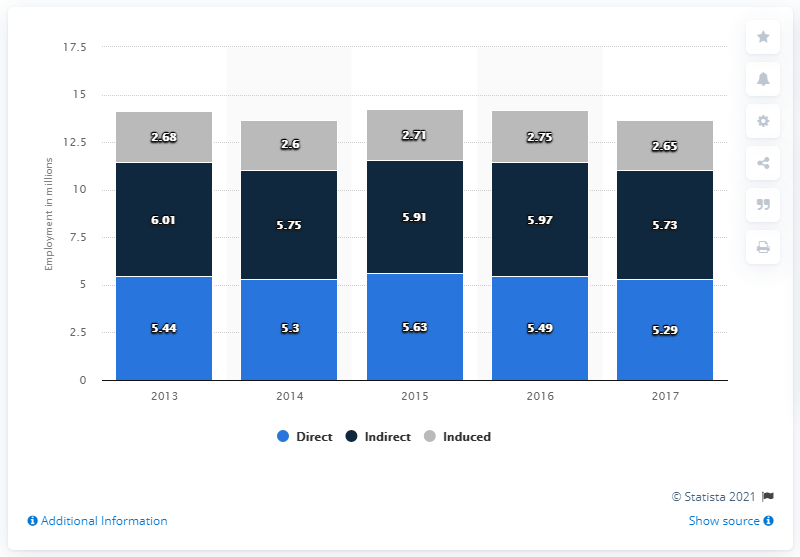Identify some key points in this picture. In 2017, the travel and tourism industry directly contributed 5.29 million jobs to the U.S. economy. 